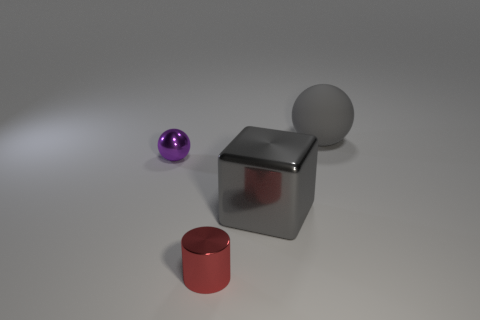Add 3 tiny cylinders. How many objects exist? 7 Subtract 1 cylinders. How many cylinders are left? 0 Add 2 gray rubber things. How many gray rubber things are left? 3 Add 4 metallic cylinders. How many metallic cylinders exist? 5 Subtract all gray balls. How many balls are left? 1 Subtract 0 green balls. How many objects are left? 4 Subtract all cubes. How many objects are left? 3 Subtract all green cubes. Subtract all cyan balls. How many cubes are left? 1 Subtract all cyan shiny cubes. Subtract all tiny things. How many objects are left? 2 